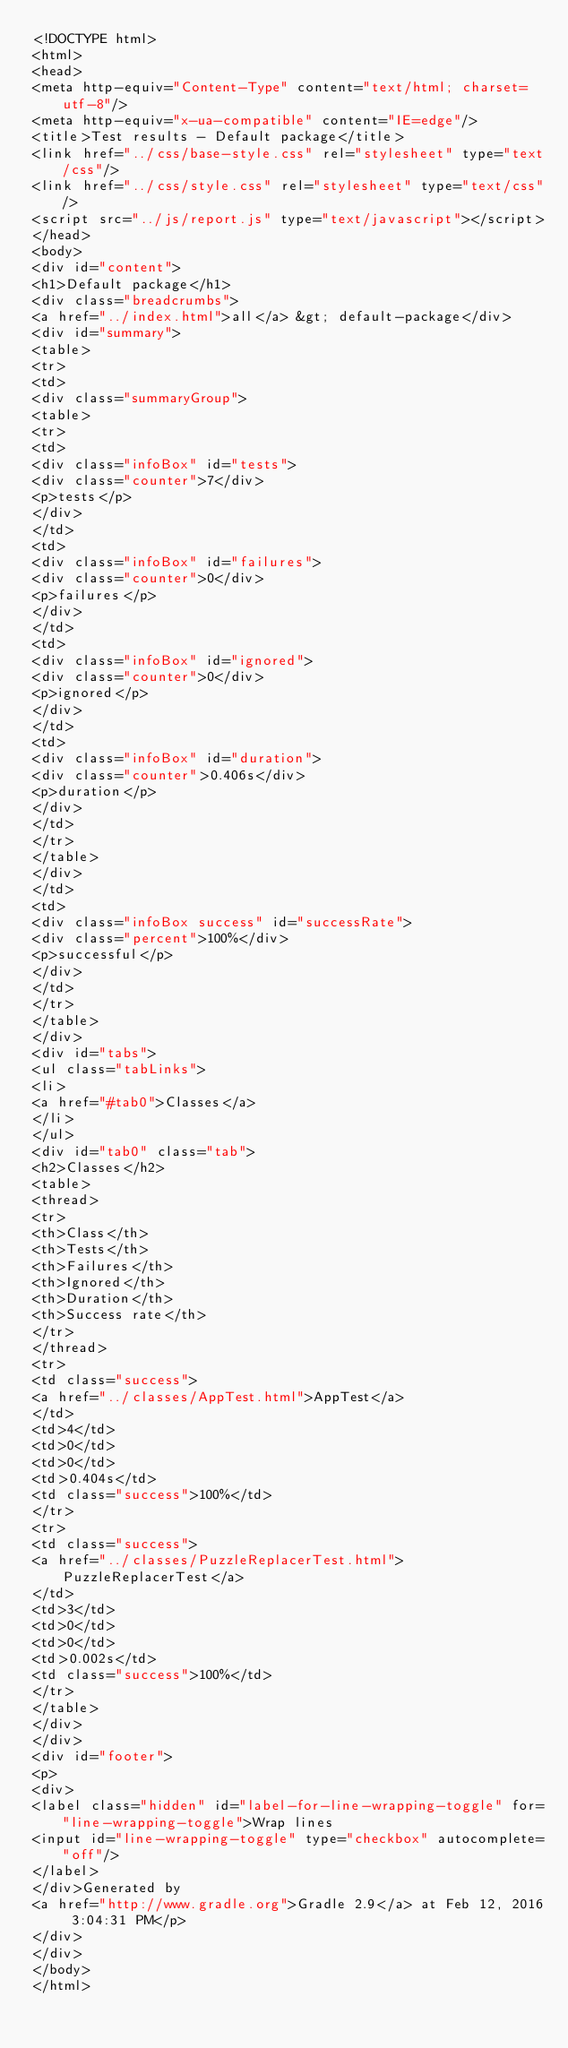Convert code to text. <code><loc_0><loc_0><loc_500><loc_500><_HTML_><!DOCTYPE html>
<html>
<head>
<meta http-equiv="Content-Type" content="text/html; charset=utf-8"/>
<meta http-equiv="x-ua-compatible" content="IE=edge"/>
<title>Test results - Default package</title>
<link href="../css/base-style.css" rel="stylesheet" type="text/css"/>
<link href="../css/style.css" rel="stylesheet" type="text/css"/>
<script src="../js/report.js" type="text/javascript"></script>
</head>
<body>
<div id="content">
<h1>Default package</h1>
<div class="breadcrumbs">
<a href="../index.html">all</a> &gt; default-package</div>
<div id="summary">
<table>
<tr>
<td>
<div class="summaryGroup">
<table>
<tr>
<td>
<div class="infoBox" id="tests">
<div class="counter">7</div>
<p>tests</p>
</div>
</td>
<td>
<div class="infoBox" id="failures">
<div class="counter">0</div>
<p>failures</p>
</div>
</td>
<td>
<div class="infoBox" id="ignored">
<div class="counter">0</div>
<p>ignored</p>
</div>
</td>
<td>
<div class="infoBox" id="duration">
<div class="counter">0.406s</div>
<p>duration</p>
</div>
</td>
</tr>
</table>
</div>
</td>
<td>
<div class="infoBox success" id="successRate">
<div class="percent">100%</div>
<p>successful</p>
</div>
</td>
</tr>
</table>
</div>
<div id="tabs">
<ul class="tabLinks">
<li>
<a href="#tab0">Classes</a>
</li>
</ul>
<div id="tab0" class="tab">
<h2>Classes</h2>
<table>
<thread>
<tr>
<th>Class</th>
<th>Tests</th>
<th>Failures</th>
<th>Ignored</th>
<th>Duration</th>
<th>Success rate</th>
</tr>
</thread>
<tr>
<td class="success">
<a href="../classes/AppTest.html">AppTest</a>
</td>
<td>4</td>
<td>0</td>
<td>0</td>
<td>0.404s</td>
<td class="success">100%</td>
</tr>
<tr>
<td class="success">
<a href="../classes/PuzzleReplacerTest.html">PuzzleReplacerTest</a>
</td>
<td>3</td>
<td>0</td>
<td>0</td>
<td>0.002s</td>
<td class="success">100%</td>
</tr>
</table>
</div>
</div>
<div id="footer">
<p>
<div>
<label class="hidden" id="label-for-line-wrapping-toggle" for="line-wrapping-toggle">Wrap lines
<input id="line-wrapping-toggle" type="checkbox" autocomplete="off"/>
</label>
</div>Generated by 
<a href="http://www.gradle.org">Gradle 2.9</a> at Feb 12, 2016 3:04:31 PM</p>
</div>
</div>
</body>
</html>
</code> 